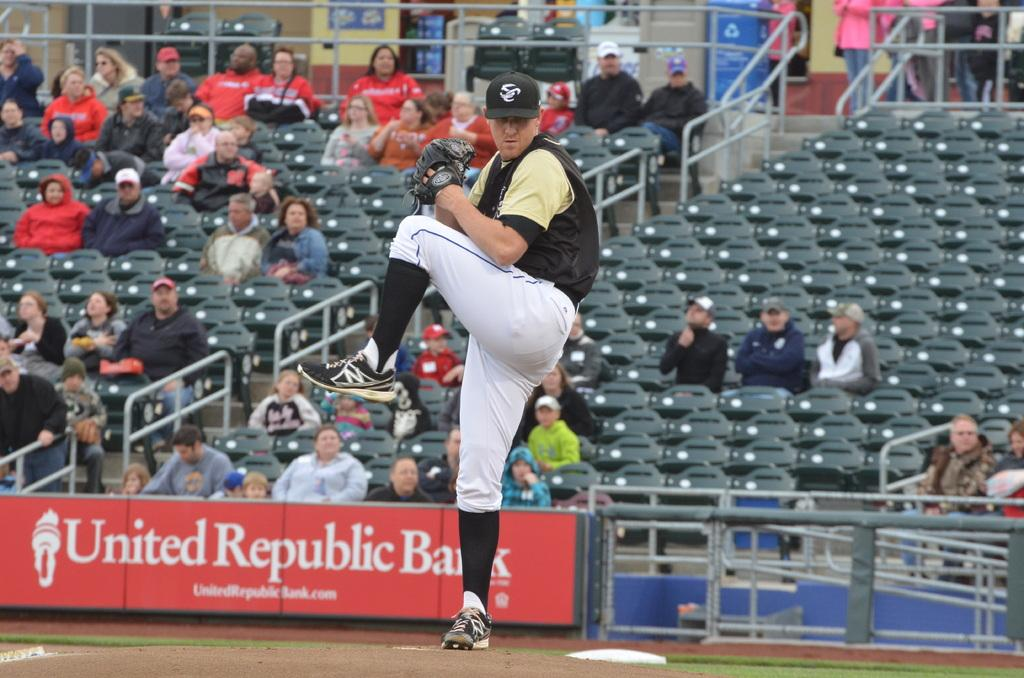<image>
Offer a succinct explanation of the picture presented. A pitcher winds up at an unknown stadium with a united republic bank banner behind him. 